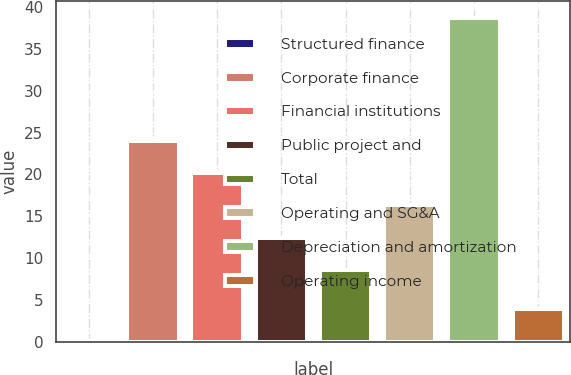Convert chart to OTSL. <chart><loc_0><loc_0><loc_500><loc_500><bar_chart><fcel>Structured finance<fcel>Corporate finance<fcel>Financial institutions<fcel>Public project and<fcel>Total<fcel>Operating and SG&A<fcel>Depreciation and amortization<fcel>Operating income<nl><fcel>0.1<fcel>24.04<fcel>20.18<fcel>12.46<fcel>8.6<fcel>16.32<fcel>38.7<fcel>3.96<nl></chart> 